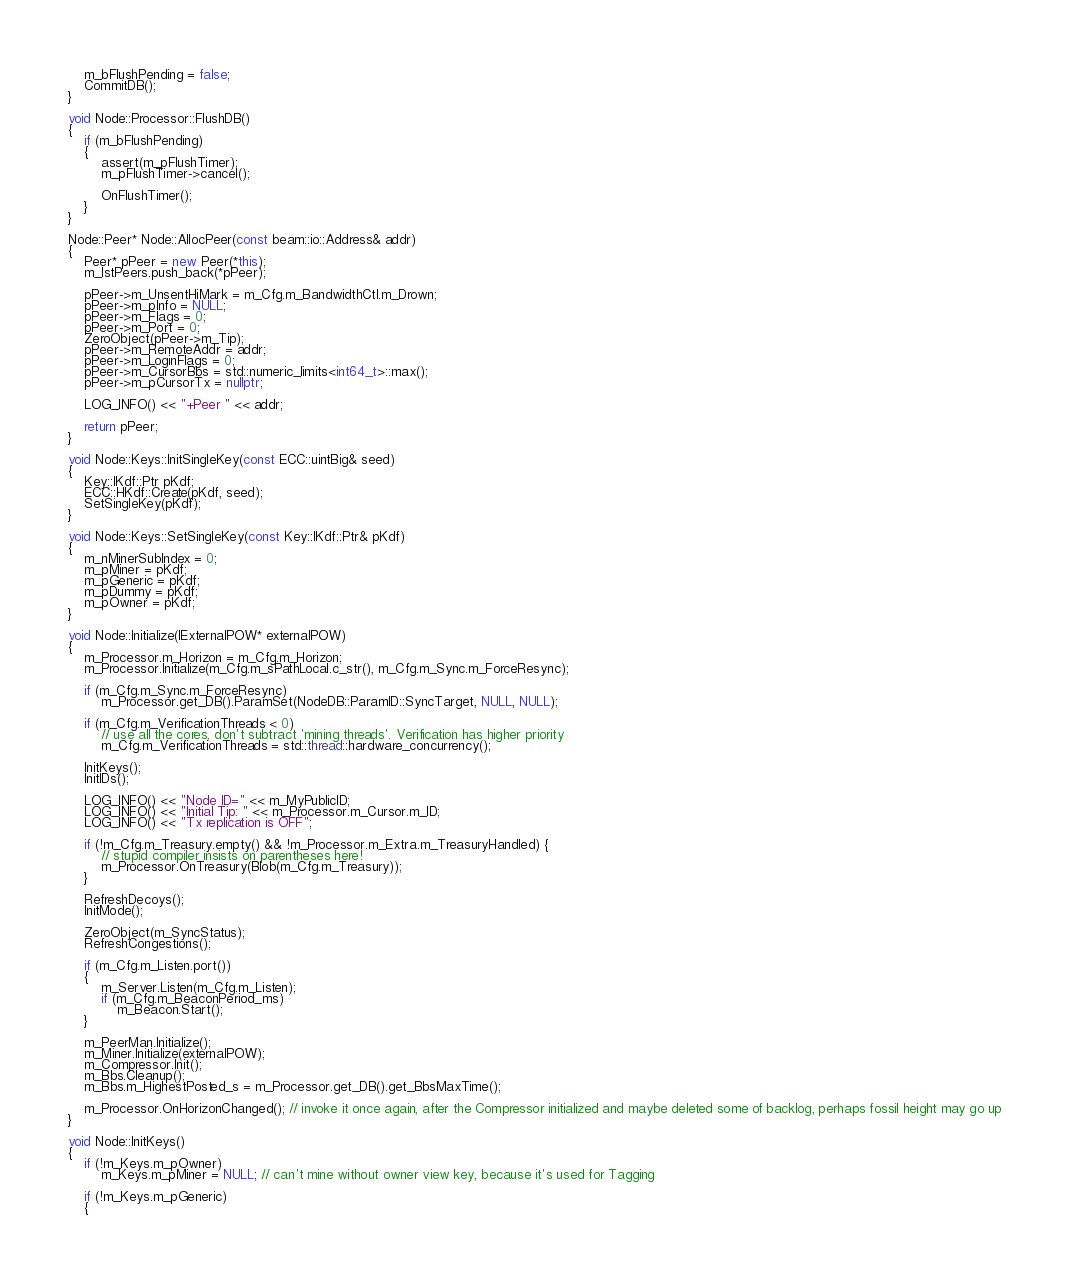<code> <loc_0><loc_0><loc_500><loc_500><_C++_>    m_bFlushPending = false;
    CommitDB();
}

void Node::Processor::FlushDB()
{
    if (m_bFlushPending)
    {
        assert(m_pFlushTimer);
        m_pFlushTimer->cancel();

        OnFlushTimer();
    }
}

Node::Peer* Node::AllocPeer(const beam::io::Address& addr)
{
    Peer* pPeer = new Peer(*this);
    m_lstPeers.push_back(*pPeer);

	pPeer->m_UnsentHiMark = m_Cfg.m_BandwidthCtl.m_Drown;
    pPeer->m_pInfo = NULL;
    pPeer->m_Flags = 0;
    pPeer->m_Port = 0;
    ZeroObject(pPeer->m_Tip);
    pPeer->m_RemoteAddr = addr;
    pPeer->m_LoginFlags = 0;
	pPeer->m_CursorBbs = std::numeric_limits<int64_t>::max();
	pPeer->m_pCursorTx = nullptr;

    LOG_INFO() << "+Peer " << addr;

    return pPeer;
}

void Node::Keys::InitSingleKey(const ECC::uintBig& seed)
{
    Key::IKdf::Ptr pKdf;
    ECC::HKdf::Create(pKdf, seed);
    SetSingleKey(pKdf);
}

void Node::Keys::SetSingleKey(const Key::IKdf::Ptr& pKdf)
{
    m_nMinerSubIndex = 0;
    m_pMiner = pKdf;
    m_pGeneric = pKdf;
    m_pDummy = pKdf;
    m_pOwner = pKdf;
}

void Node::Initialize(IExternalPOW* externalPOW)
{
    m_Processor.m_Horizon = m_Cfg.m_Horizon;
    m_Processor.Initialize(m_Cfg.m_sPathLocal.c_str(), m_Cfg.m_Sync.m_ForceResync);

    if (m_Cfg.m_Sync.m_ForceResync)
        m_Processor.get_DB().ParamSet(NodeDB::ParamID::SyncTarget, NULL, NULL);

    if (m_Cfg.m_VerificationThreads < 0)
        // use all the cores, don't subtract 'mining threads'. Verification has higher priority
        m_Cfg.m_VerificationThreads = std::thread::hardware_concurrency();

    InitKeys();
    InitIDs();

    LOG_INFO() << "Node ID=" << m_MyPublicID;
    LOG_INFO() << "Initial Tip: " << m_Processor.m_Cursor.m_ID;
	LOG_INFO() << "Tx replication is OFF";

	if (!m_Cfg.m_Treasury.empty() && !m_Processor.m_Extra.m_TreasuryHandled) {
		// stupid compiler insists on parentheses here!
		m_Processor.OnTreasury(Blob(m_Cfg.m_Treasury));
	}

	RefreshDecoys();
    InitMode();

	ZeroObject(m_SyncStatus);
    RefreshCongestions();

    if (m_Cfg.m_Listen.port())
    {
        m_Server.Listen(m_Cfg.m_Listen);
        if (m_Cfg.m_BeaconPeriod_ms)
            m_Beacon.Start();
    }

    m_PeerMan.Initialize();
    m_Miner.Initialize(externalPOW);
    m_Compressor.Init();
    m_Bbs.Cleanup();
	m_Bbs.m_HighestPosted_s = m_Processor.get_DB().get_BbsMaxTime();

	m_Processor.OnHorizonChanged(); // invoke it once again, after the Compressor initialized and maybe deleted some of backlog, perhaps fossil height may go up
}

void Node::InitKeys()
{
    if (!m_Keys.m_pOwner)
        m_Keys.m_pMiner = NULL; // can't mine without owner view key, because it's used for Tagging

    if (!m_Keys.m_pGeneric)
    {</code> 